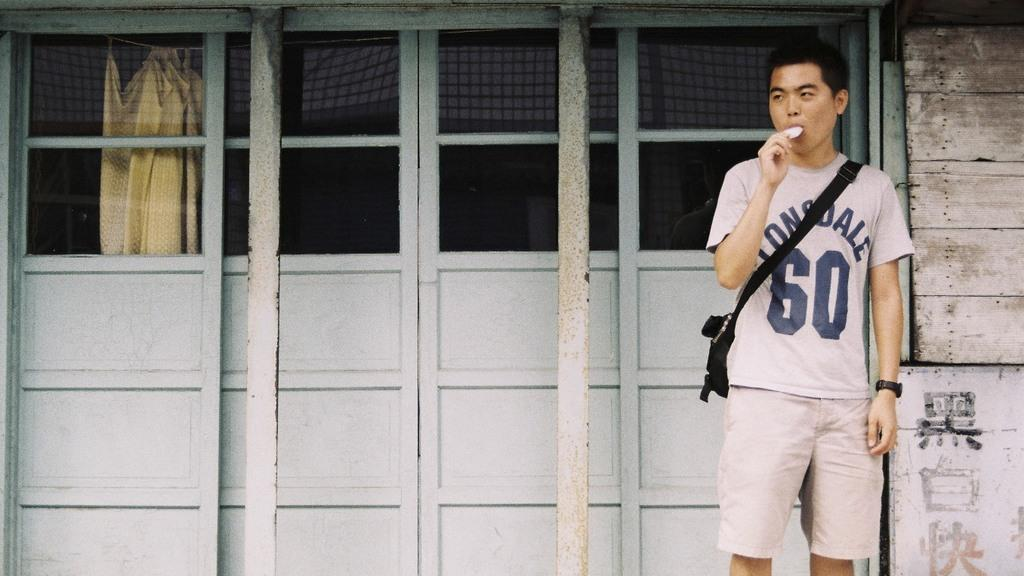<image>
Render a clear and concise summary of the photo. a man with a sidestrap purse eating a pop wearing a shirt number 60 